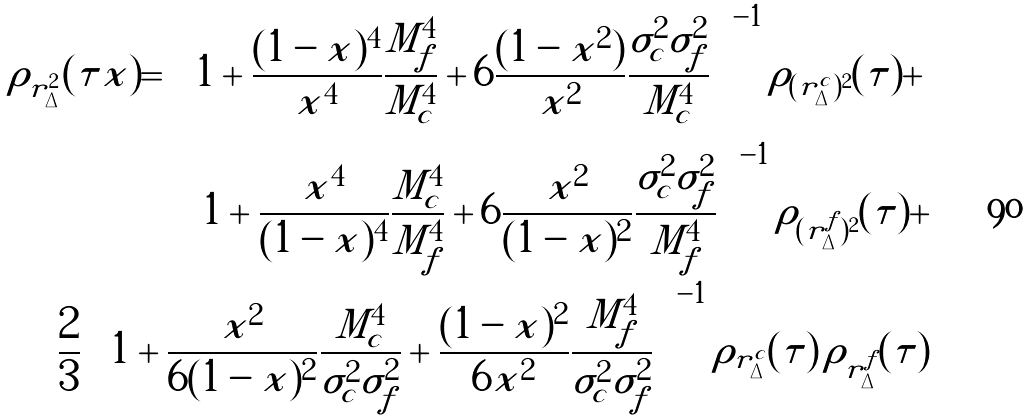Convert formula to latex. <formula><loc_0><loc_0><loc_500><loc_500>\rho _ { r _ { \Delta } ^ { 2 } } ( \tau | x ) = \left [ 1 + \frac { ( 1 - x ) ^ { 4 } } { x ^ { 4 } } \frac { M _ { f } ^ { 4 } } { M _ { c } ^ { 4 } } + 6 \frac { ( 1 - x ^ { 2 } ) } { x ^ { 2 } } \frac { \sigma _ { c } ^ { 2 } \sigma _ { f } ^ { 2 } } { M _ { c } ^ { 4 } } \right ] ^ { - 1 } \rho _ { ( r _ { \Delta } ^ { c } ) ^ { 2 } } ( \tau ) + \\ \left [ 1 + \frac { x ^ { 4 } } { ( 1 - x ) ^ { 4 } } \frac { M _ { c } ^ { 4 } } { M _ { f } ^ { 4 } } + 6 \frac { x ^ { 2 } } { ( 1 - x ) ^ { 2 } } \frac { \sigma _ { c } ^ { 2 } \sigma _ { f } ^ { 2 } } { M _ { f } ^ { 4 } } \right ] ^ { - 1 } \rho _ { ( r _ { \Delta } ^ { f } ) ^ { 2 } } ( \tau ) + \\ \frac { 2 } { 3 } \left [ 1 + \frac { x ^ { 2 } } { 6 ( 1 - x ) ^ { 2 } } \frac { M _ { c } ^ { 4 } } { \sigma _ { c } ^ { 2 } \sigma _ { f } ^ { 2 } } + \frac { ( 1 - x ) ^ { 2 } } { 6 x ^ { 2 } } \frac { M _ { f } ^ { 4 } } { \sigma _ { c } ^ { 2 } \sigma _ { f } ^ { 2 } } \right ] ^ { - 1 } \rho _ { r _ { \Delta } ^ { c } } ( \tau ) \, \rho _ { r _ { \Delta } ^ { f } } ( \tau )</formula> 